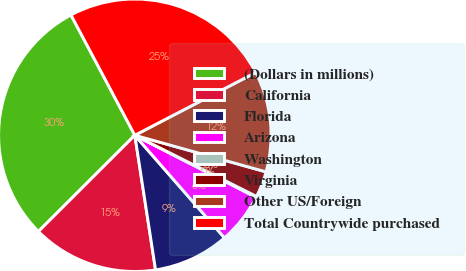Convert chart. <chart><loc_0><loc_0><loc_500><loc_500><pie_chart><fcel>(Dollars in millions)<fcel>California<fcel>Florida<fcel>Arizona<fcel>Washington<fcel>Virginia<fcel>Other US/Foreign<fcel>Total Countrywide purchased<nl><fcel>29.72%<fcel>14.95%<fcel>9.0%<fcel>6.04%<fcel>0.12%<fcel>3.08%<fcel>11.96%<fcel>25.14%<nl></chart> 